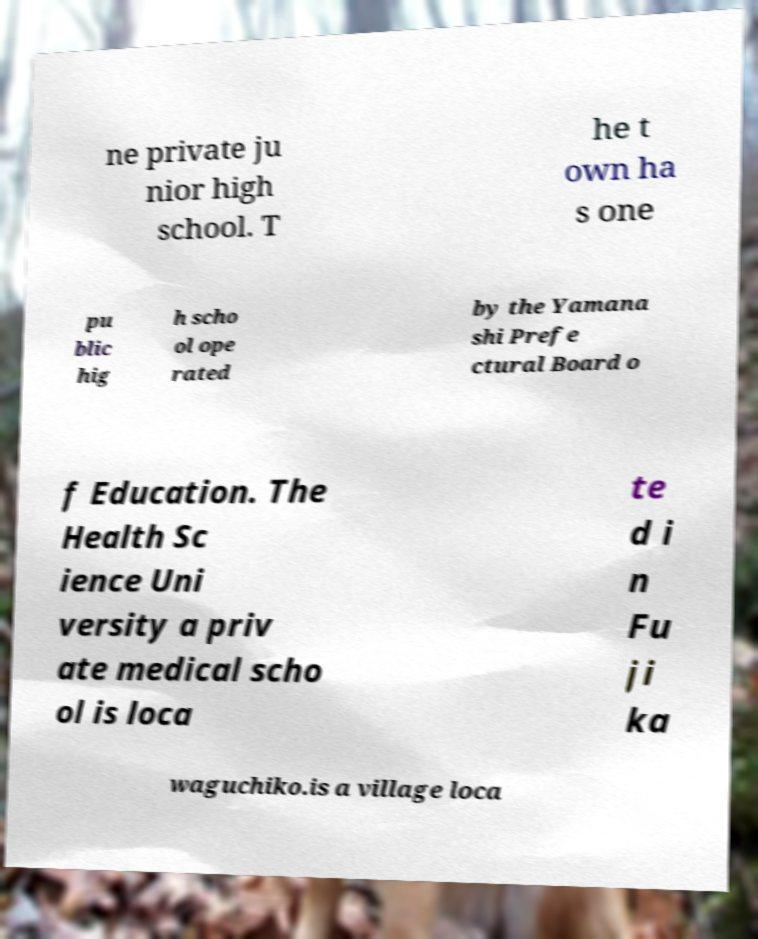Can you read and provide the text displayed in the image?This photo seems to have some interesting text. Can you extract and type it out for me? ne private ju nior high school. T he t own ha s one pu blic hig h scho ol ope rated by the Yamana shi Prefe ctural Board o f Education. The Health Sc ience Uni versity a priv ate medical scho ol is loca te d i n Fu ji ka waguchiko.is a village loca 